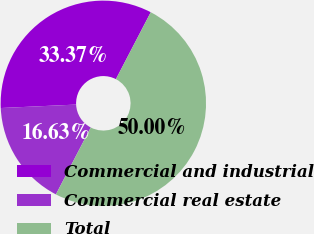Convert chart. <chart><loc_0><loc_0><loc_500><loc_500><pie_chart><fcel>Commercial and industrial<fcel>Commercial real estate<fcel>Total<nl><fcel>33.37%<fcel>16.63%<fcel>50.0%<nl></chart> 